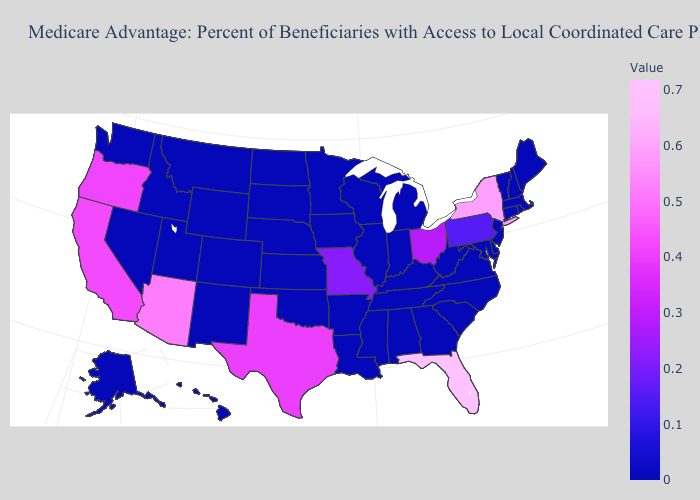Does Arizona have the highest value in the West?
Concise answer only. Yes. Among the states that border South Dakota , which have the lowest value?
Answer briefly. Iowa, Minnesota, Montana, North Dakota, Nebraska, Wyoming. 